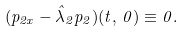Convert formula to latex. <formula><loc_0><loc_0><loc_500><loc_500>( p _ { 2 x } - \hat { \lambda } _ { 2 } p _ { 2 } ) ( t , \, 0 ) \equiv 0 .</formula> 